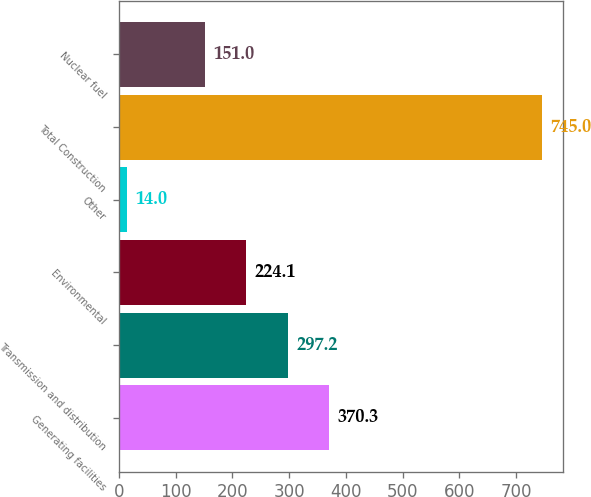Convert chart to OTSL. <chart><loc_0><loc_0><loc_500><loc_500><bar_chart><fcel>Generating facilities<fcel>Transmission and distribution<fcel>Environmental<fcel>Other<fcel>Total Construction<fcel>Nuclear fuel<nl><fcel>370.3<fcel>297.2<fcel>224.1<fcel>14<fcel>745<fcel>151<nl></chart> 